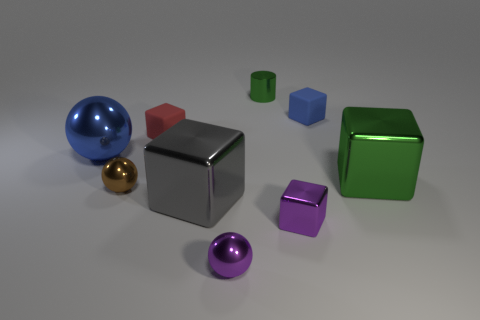Could you suggest a theme that this collection of objects might represent? The collection could represent themes of diversity and unity. Despite the different colors, shapes, and sizes of the objects, they coexist harmoniously within the same space. This can be a metaphor for a society in which diverse individuals, each with unique characteristics, come together to form a coherent community. 